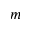<formula> <loc_0><loc_0><loc_500><loc_500>m</formula> 